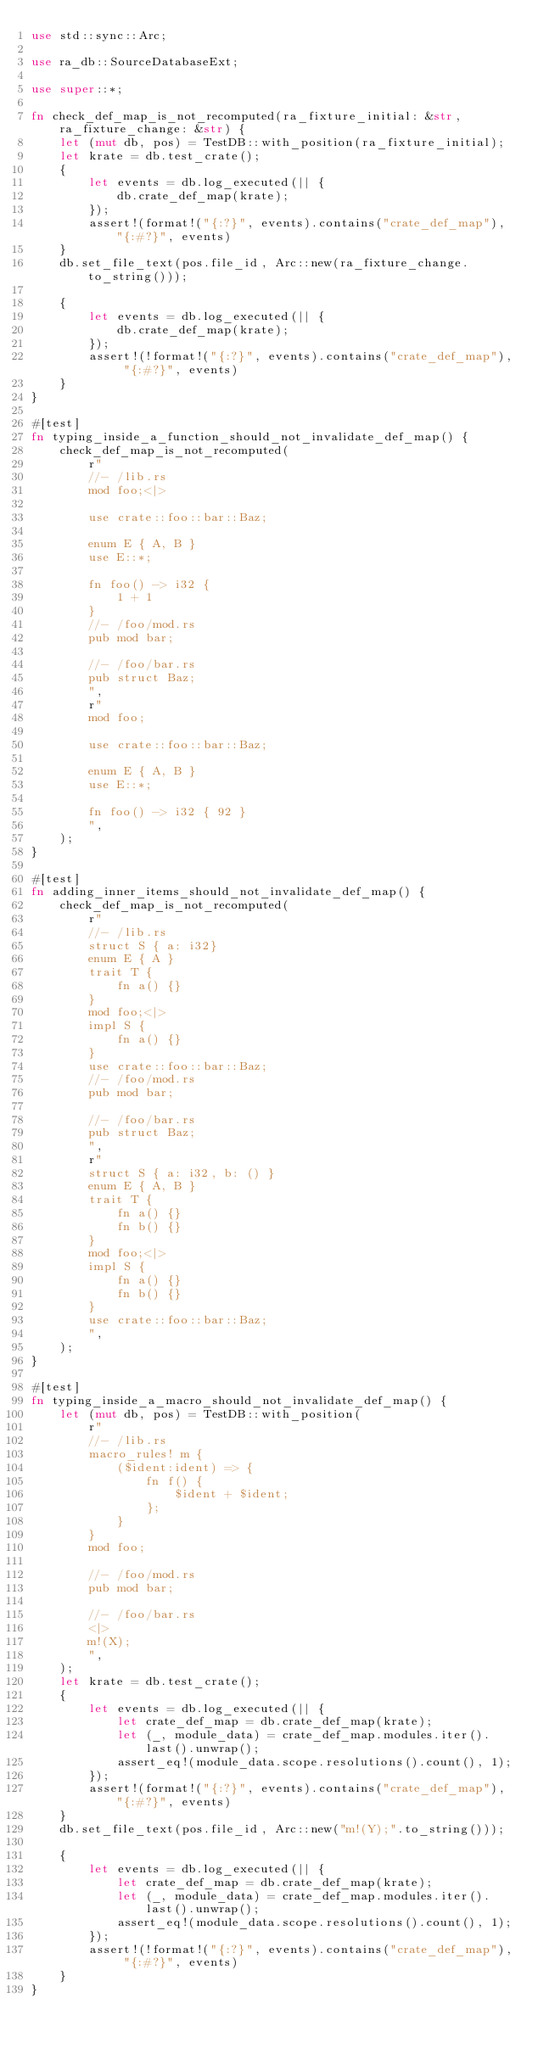Convert code to text. <code><loc_0><loc_0><loc_500><loc_500><_Rust_>use std::sync::Arc;

use ra_db::SourceDatabaseExt;

use super::*;

fn check_def_map_is_not_recomputed(ra_fixture_initial: &str, ra_fixture_change: &str) {
    let (mut db, pos) = TestDB::with_position(ra_fixture_initial);
    let krate = db.test_crate();
    {
        let events = db.log_executed(|| {
            db.crate_def_map(krate);
        });
        assert!(format!("{:?}", events).contains("crate_def_map"), "{:#?}", events)
    }
    db.set_file_text(pos.file_id, Arc::new(ra_fixture_change.to_string()));

    {
        let events = db.log_executed(|| {
            db.crate_def_map(krate);
        });
        assert!(!format!("{:?}", events).contains("crate_def_map"), "{:#?}", events)
    }
}

#[test]
fn typing_inside_a_function_should_not_invalidate_def_map() {
    check_def_map_is_not_recomputed(
        r"
        //- /lib.rs
        mod foo;<|>

        use crate::foo::bar::Baz;

        enum E { A, B }
        use E::*;

        fn foo() -> i32 {
            1 + 1
        }
        //- /foo/mod.rs
        pub mod bar;

        //- /foo/bar.rs
        pub struct Baz;
        ",
        r"
        mod foo;

        use crate::foo::bar::Baz;

        enum E { A, B }
        use E::*;

        fn foo() -> i32 { 92 }
        ",
    );
}

#[test]
fn adding_inner_items_should_not_invalidate_def_map() {
    check_def_map_is_not_recomputed(
        r"
        //- /lib.rs
        struct S { a: i32}
        enum E { A }
        trait T {
            fn a() {}
        }
        mod foo;<|>
        impl S {
            fn a() {}
        }
        use crate::foo::bar::Baz;
        //- /foo/mod.rs
        pub mod bar;

        //- /foo/bar.rs
        pub struct Baz;
        ",
        r"
        struct S { a: i32, b: () }
        enum E { A, B }
        trait T {
            fn a() {}
            fn b() {}
        }
        mod foo;<|>
        impl S {
            fn a() {}
            fn b() {}
        }
        use crate::foo::bar::Baz;
        ",
    );
}

#[test]
fn typing_inside_a_macro_should_not_invalidate_def_map() {
    let (mut db, pos) = TestDB::with_position(
        r"
        //- /lib.rs
        macro_rules! m {
            ($ident:ident) => {
                fn f() {
                    $ident + $ident;
                };
            }
        }
        mod foo;

        //- /foo/mod.rs
        pub mod bar;

        //- /foo/bar.rs
        <|>
        m!(X);
        ",
    );
    let krate = db.test_crate();
    {
        let events = db.log_executed(|| {
            let crate_def_map = db.crate_def_map(krate);
            let (_, module_data) = crate_def_map.modules.iter().last().unwrap();
            assert_eq!(module_data.scope.resolutions().count(), 1);
        });
        assert!(format!("{:?}", events).contains("crate_def_map"), "{:#?}", events)
    }
    db.set_file_text(pos.file_id, Arc::new("m!(Y);".to_string()));

    {
        let events = db.log_executed(|| {
            let crate_def_map = db.crate_def_map(krate);
            let (_, module_data) = crate_def_map.modules.iter().last().unwrap();
            assert_eq!(module_data.scope.resolutions().count(), 1);
        });
        assert!(!format!("{:?}", events).contains("crate_def_map"), "{:#?}", events)
    }
}
</code> 